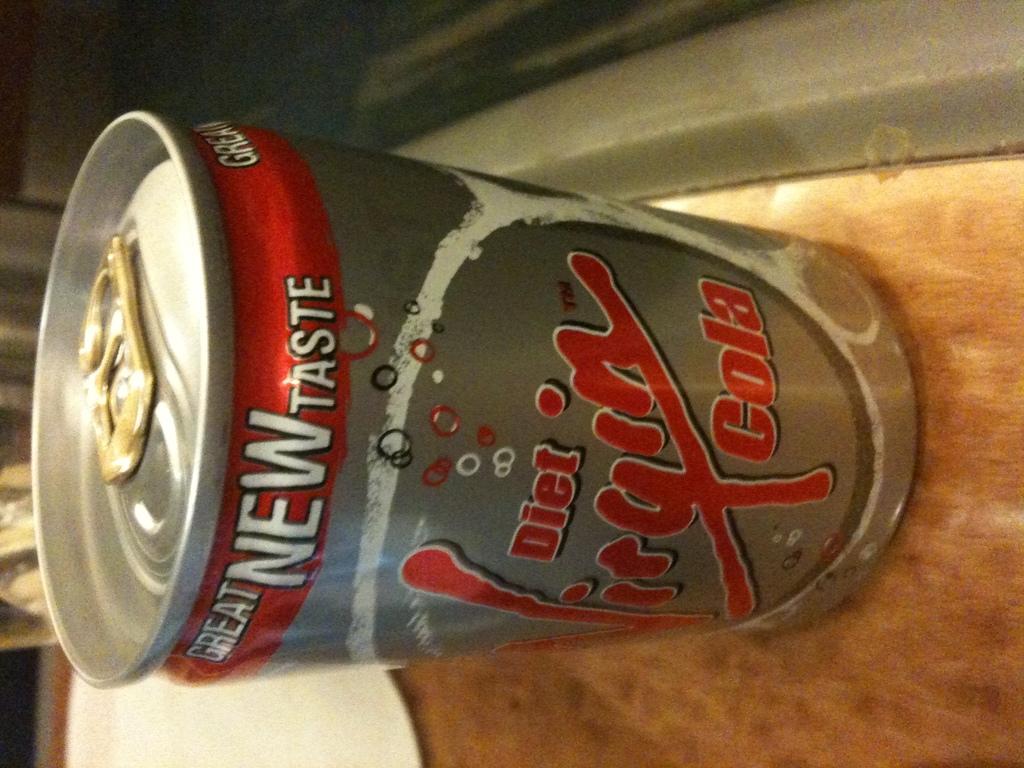What is the name of the drink?
Your response must be concise. Diet virgin cola. What brand of drink is this?
Keep it short and to the point. Diet virgin cola. 